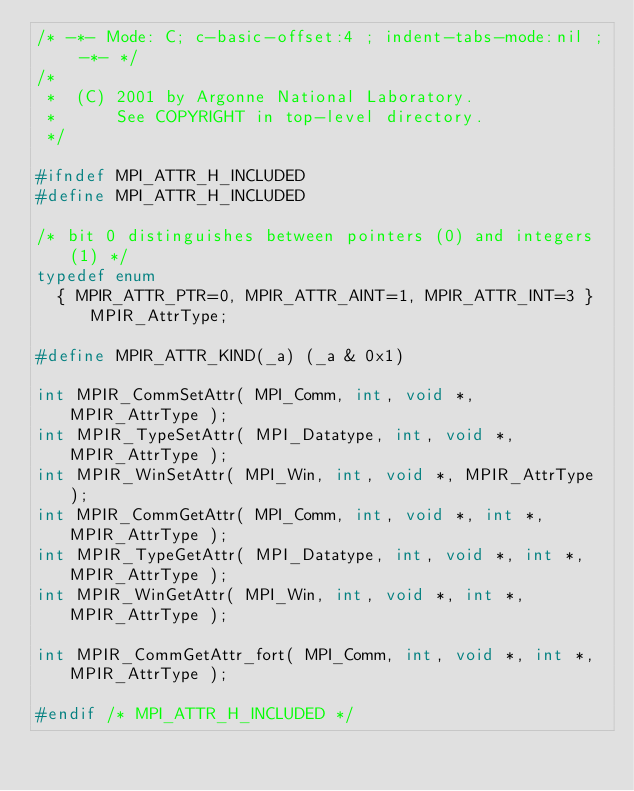Convert code to text. <code><loc_0><loc_0><loc_500><loc_500><_C_>/* -*- Mode: C; c-basic-offset:4 ; indent-tabs-mode:nil ; -*- */
/*  
 *  (C) 2001 by Argonne National Laboratory.
 *      See COPYRIGHT in top-level directory.
 */

#ifndef MPI_ATTR_H_INCLUDED
#define MPI_ATTR_H_INCLUDED

/* bit 0 distinguishes between pointers (0) and integers (1) */
typedef enum
  { MPIR_ATTR_PTR=0, MPIR_ATTR_AINT=1, MPIR_ATTR_INT=3 } MPIR_AttrType;

#define MPIR_ATTR_KIND(_a) (_a & 0x1)

int MPIR_CommSetAttr( MPI_Comm, int, void *, MPIR_AttrType );
int MPIR_TypeSetAttr( MPI_Datatype, int, void *, MPIR_AttrType );
int MPIR_WinSetAttr( MPI_Win, int, void *, MPIR_AttrType );
int MPIR_CommGetAttr( MPI_Comm, int, void *, int *, MPIR_AttrType );
int MPIR_TypeGetAttr( MPI_Datatype, int, void *, int *, MPIR_AttrType );
int MPIR_WinGetAttr( MPI_Win, int, void *, int *, MPIR_AttrType );

int MPIR_CommGetAttr_fort( MPI_Comm, int, void *, int *, MPIR_AttrType );

#endif /* MPI_ATTR_H_INCLUDED */
</code> 